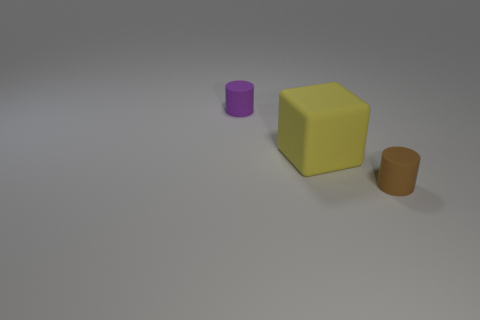Add 1 large yellow cubes. How many objects exist? 4 Subtract 1 cylinders. How many cylinders are left? 1 Subtract all large yellow objects. Subtract all purple matte objects. How many objects are left? 1 Add 2 large yellow blocks. How many large yellow blocks are left? 3 Add 2 yellow objects. How many yellow objects exist? 3 Subtract all brown cylinders. How many cylinders are left? 1 Subtract 0 blue blocks. How many objects are left? 3 Subtract all blocks. How many objects are left? 2 Subtract all blue cylinders. Subtract all brown balls. How many cylinders are left? 2 Subtract all brown balls. How many green blocks are left? 0 